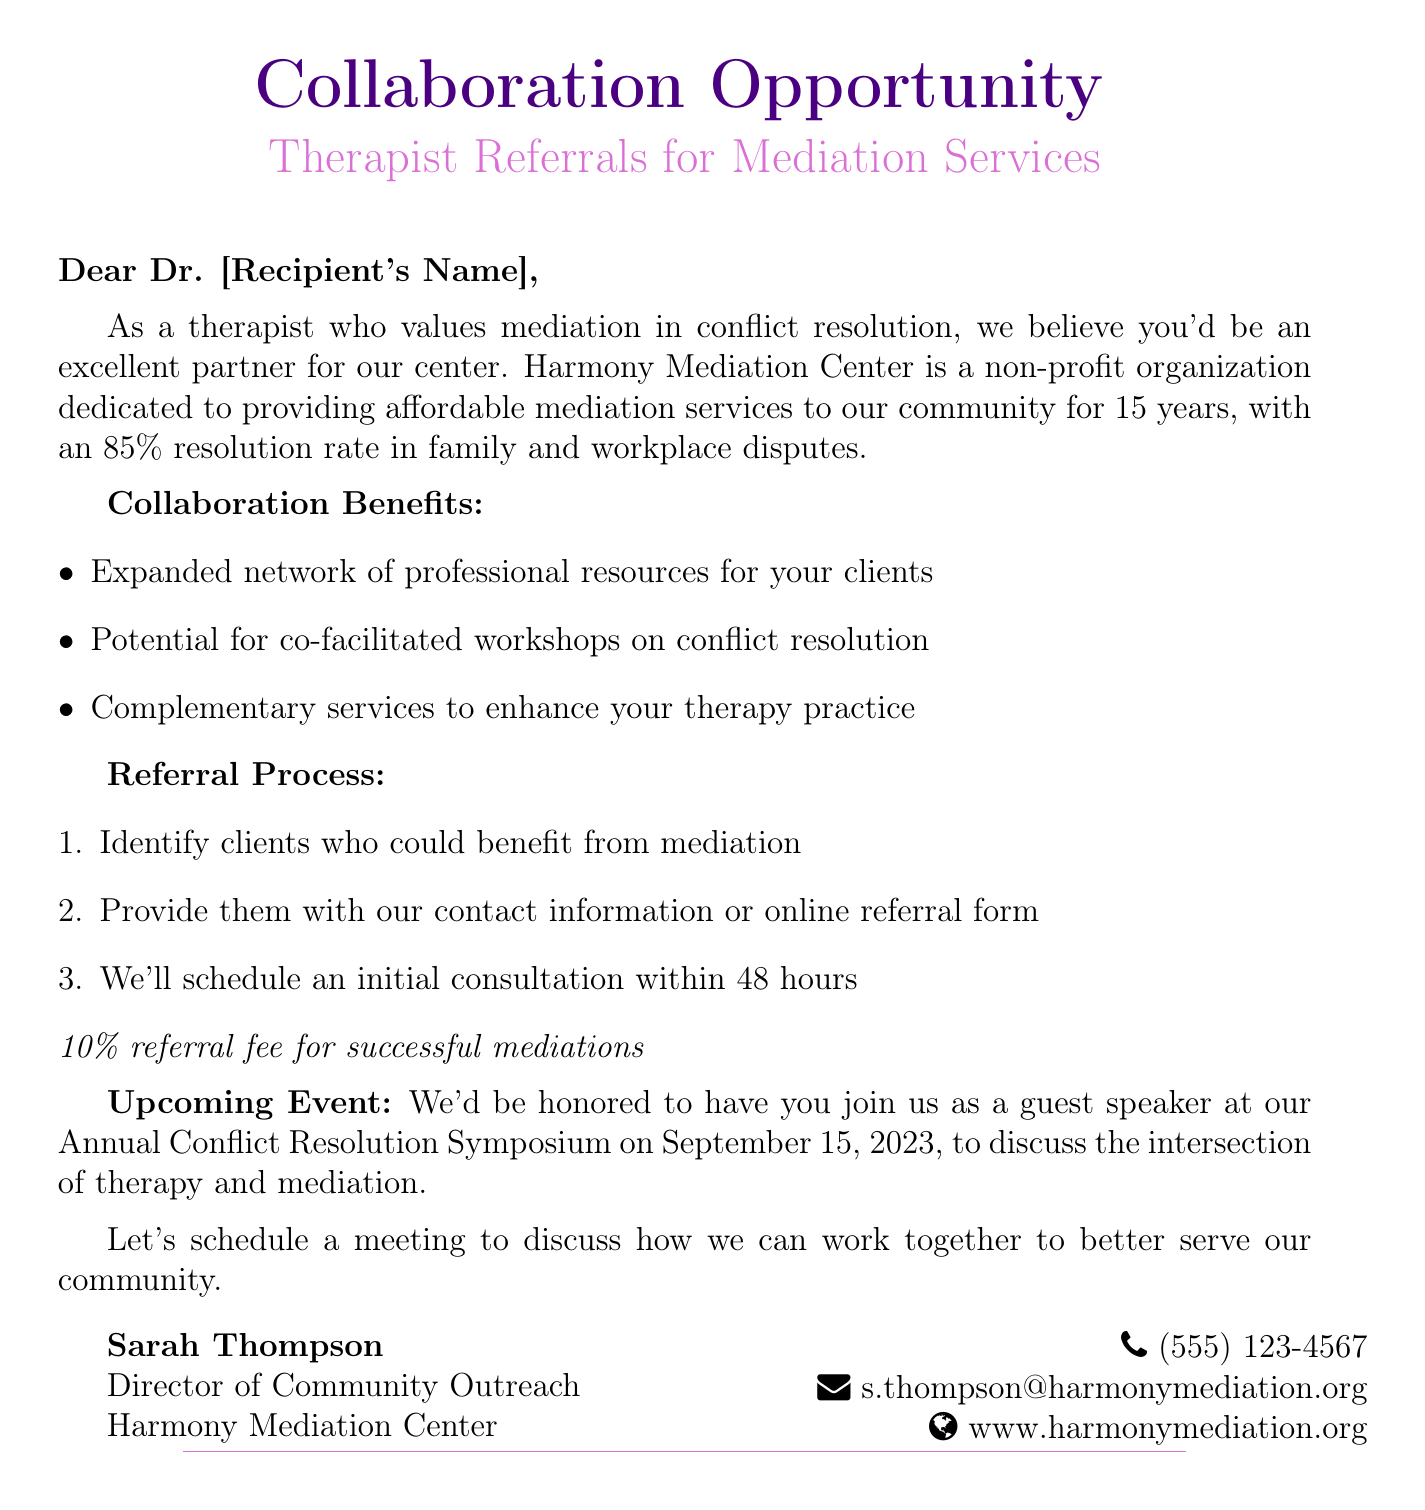What is the subject of the email? The subject of the email is clearly stated at the beginning of the document.
Answer: Collaboration Opportunity: Therapist Referrals for Mediation Services Who is the sender of the email? The sender's information is provided, including their name and position.
Answer: Sarah Thompson What is the success rate mentioned for mediation services? The document specifies a particular success rate for mediation services offered by Harmony Mediation Center.
Answer: 85% resolution rate What are the three benefits of collaboration listed in the email? The email enumerates three specific benefits regarding the collaboration.
Answer: Expanded network, co-facilitated workshops, complementary services What is the date of the upcoming Annual Conflict Resolution Symposium? The document provides a specific date for the mentioned event.
Answer: September 15, 2023 How long has Harmony Mediation Center been in operation? The document clearly states the number of years the center has been operating.
Answer: 15 years What percentage is the referral fee for successful mediations? The fee structure is mentioned in the referral process section.
Answer: 10% What action does the email suggest at the end? The email concludes with a request for a specific next step.
Answer: Schedule a meeting 